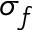<formula> <loc_0><loc_0><loc_500><loc_500>\sigma _ { f }</formula> 